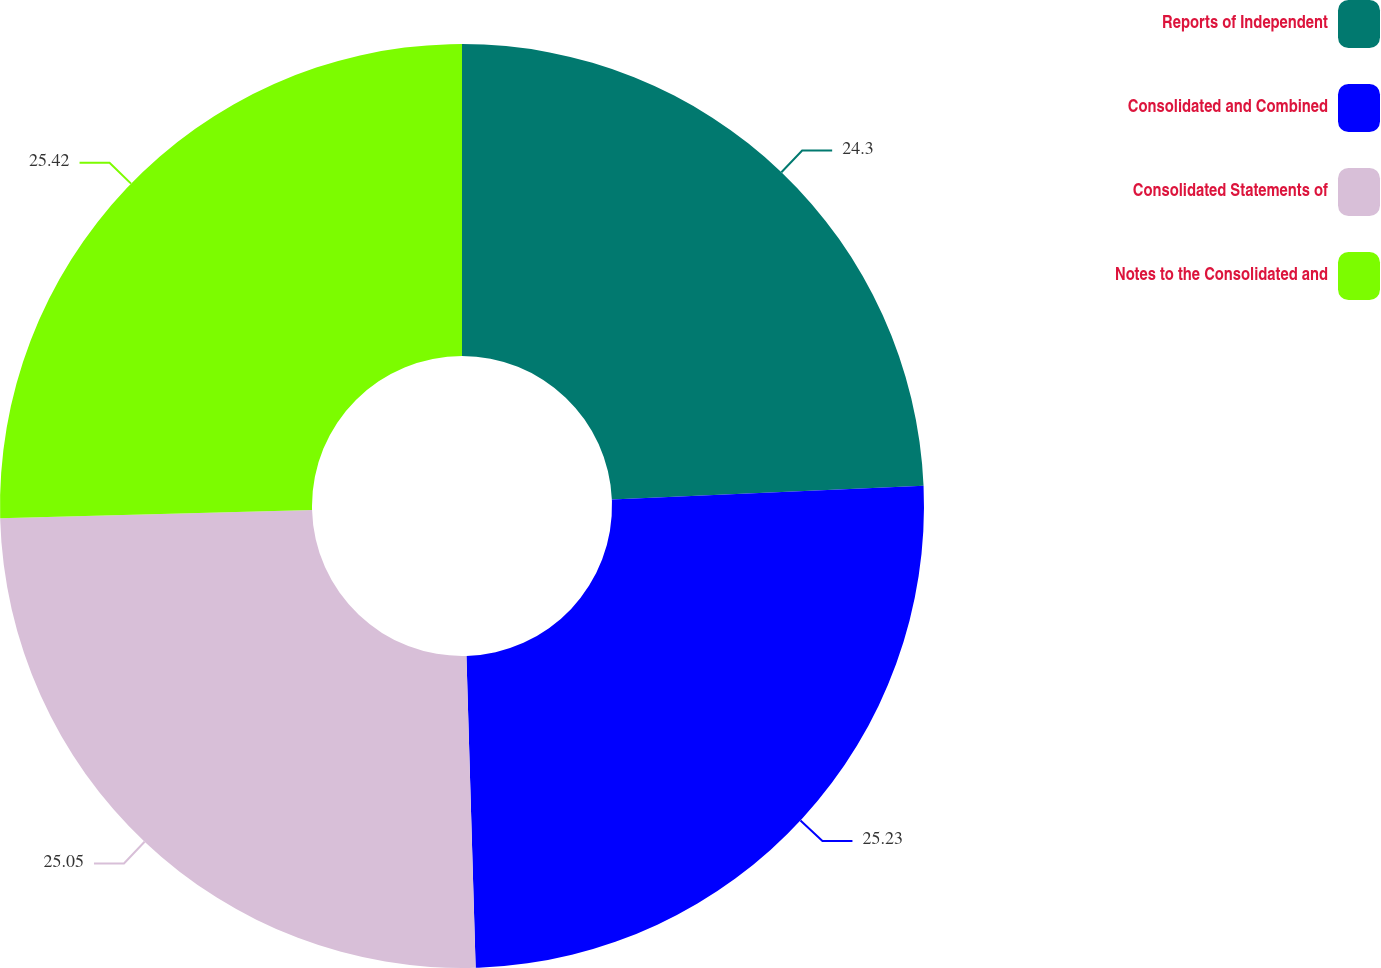<chart> <loc_0><loc_0><loc_500><loc_500><pie_chart><fcel>Reports of Independent<fcel>Consolidated and Combined<fcel>Consolidated Statements of<fcel>Notes to the Consolidated and<nl><fcel>24.3%<fcel>25.23%<fcel>25.05%<fcel>25.42%<nl></chart> 